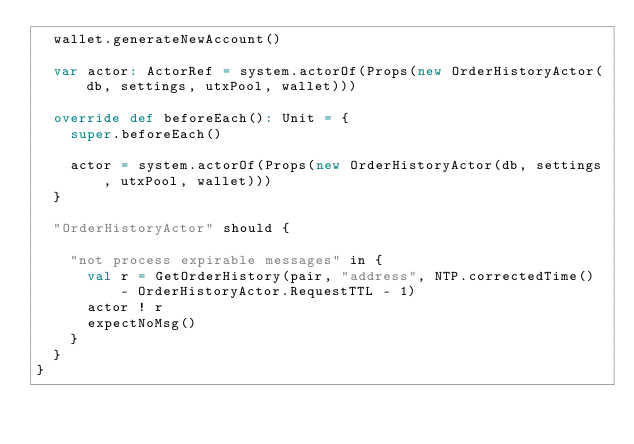<code> <loc_0><loc_0><loc_500><loc_500><_Scala_>  wallet.generateNewAccount()

  var actor: ActorRef = system.actorOf(Props(new OrderHistoryActor(db, settings, utxPool, wallet)))

  override def beforeEach(): Unit = {
    super.beforeEach()

    actor = system.actorOf(Props(new OrderHistoryActor(db, settings, utxPool, wallet)))
  }

  "OrderHistoryActor" should {

    "not process expirable messages" in {
      val r = GetOrderHistory(pair, "address", NTP.correctedTime() - OrderHistoryActor.RequestTTL - 1)
      actor ! r
      expectNoMsg()
    }
  }
}
</code> 